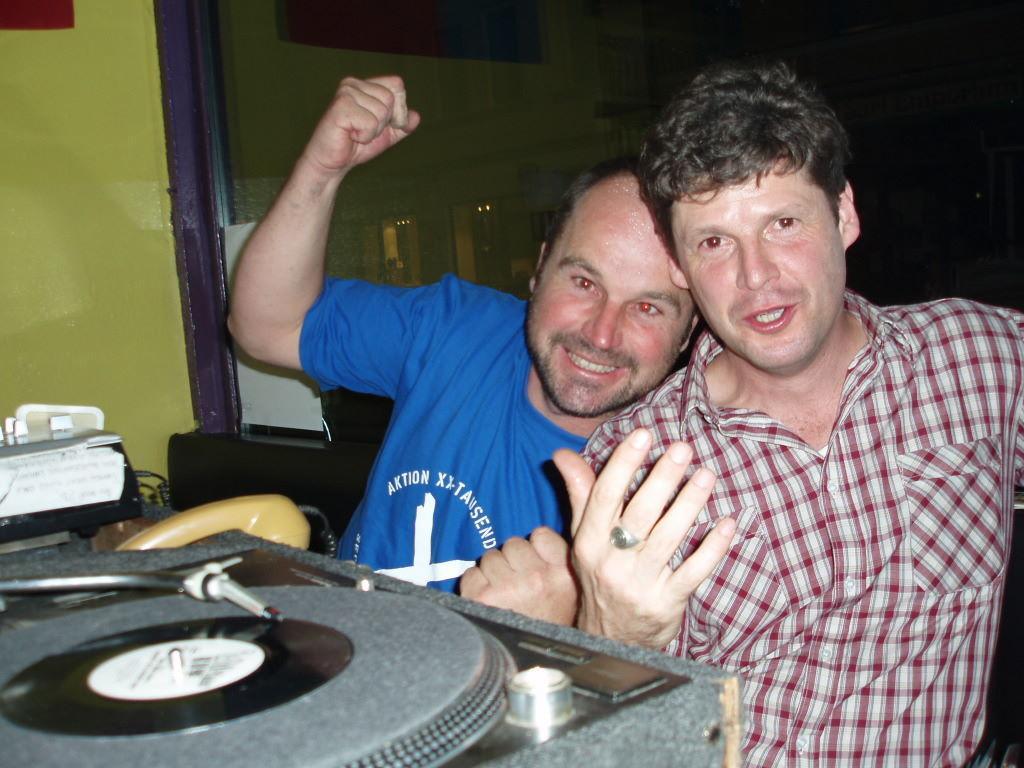In one or two sentences, can you explain what this image depicts? In this image there are two men who are sitting one beside the other by keeping their heads on each other. The man on the left side is raising his hand. In front of them there is a speaker. In the background there is a glass. On the left side top there is a wall. 